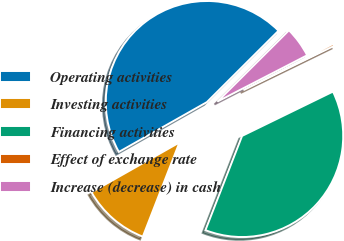Convert chart to OTSL. <chart><loc_0><loc_0><loc_500><loc_500><pie_chart><fcel>Operating activities<fcel>Investing activities<fcel>Financing activities<fcel>Effect of exchange rate<fcel>Increase (decrease) in cash<nl><fcel>45.73%<fcel>10.9%<fcel>38.13%<fcel>0.36%<fcel>4.89%<nl></chart> 